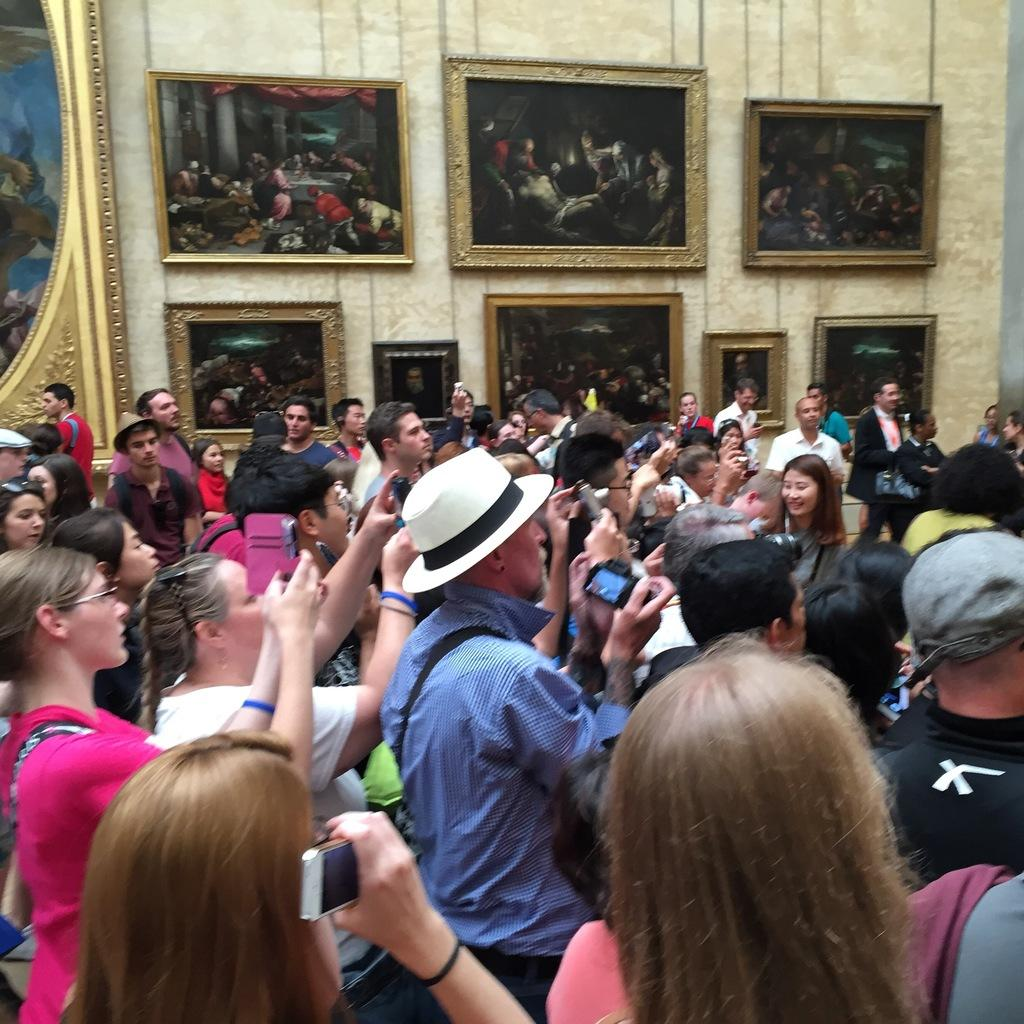How many people are present in the image? There are many people in the image. Can you describe the attire of one of the people? One person is wearing a hat. What are some people doing in the image? Some people are holding mobile phones and some are holding cameras. What can be seen in the background of the image? There is a wall with photo frames in the background. What type of pain can be heard in the background of the image? There is no sound or indication of pain in the image; it is a visual representation of people and their activities. 